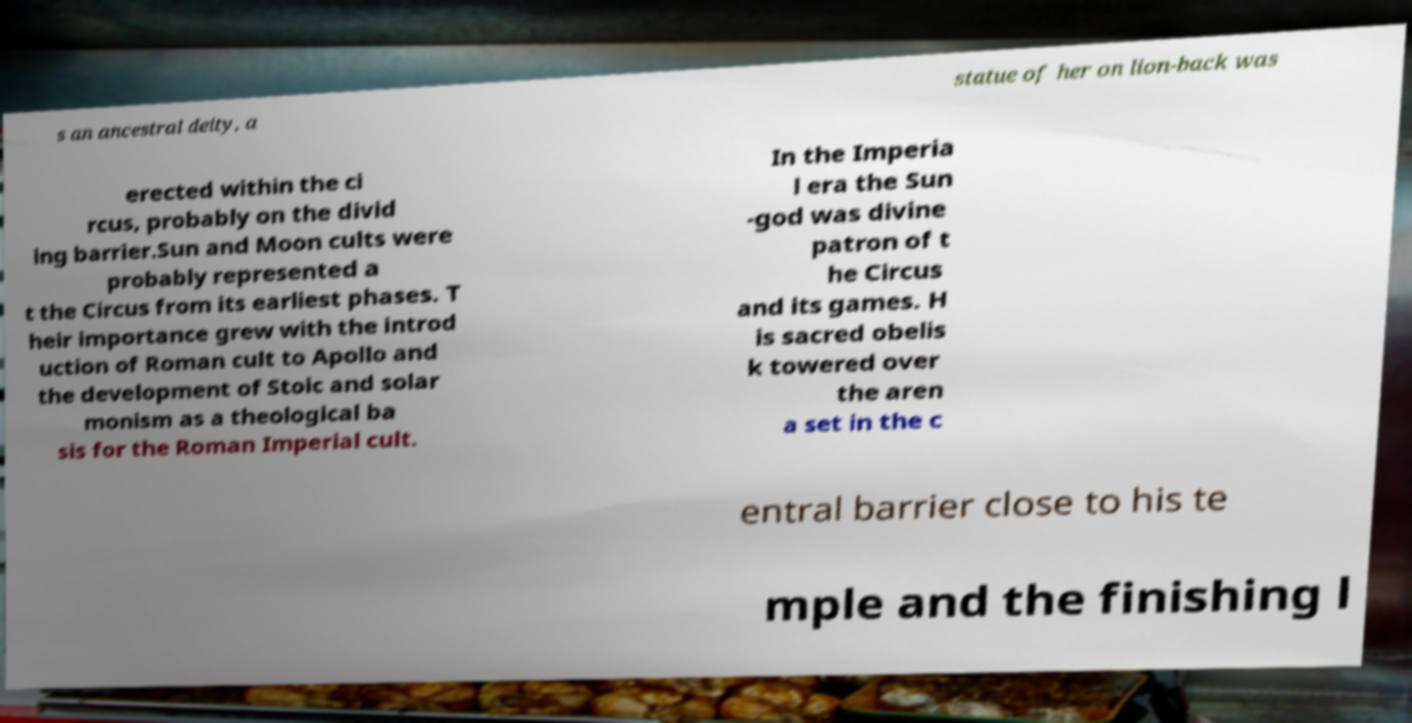What messages or text are displayed in this image? I need them in a readable, typed format. s an ancestral deity, a statue of her on lion-back was erected within the ci rcus, probably on the divid ing barrier.Sun and Moon cults were probably represented a t the Circus from its earliest phases. T heir importance grew with the introd uction of Roman cult to Apollo and the development of Stoic and solar monism as a theological ba sis for the Roman Imperial cult. In the Imperia l era the Sun -god was divine patron of t he Circus and its games. H is sacred obelis k towered over the aren a set in the c entral barrier close to his te mple and the finishing l 